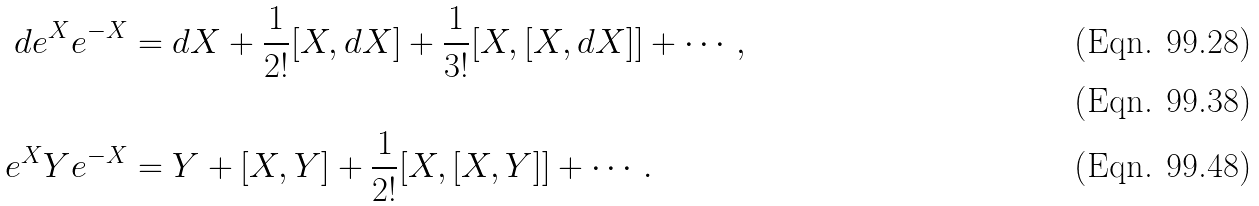<formula> <loc_0><loc_0><loc_500><loc_500>d e ^ { X } e ^ { - X } & = d X + \frac { 1 } { 2 ! } [ X , d X ] + \frac { 1 } { 3 ! } [ X , [ X , d X ] ] + \cdots , \\ \\ e ^ { X } Y e ^ { - X } & = Y + [ X , Y ] + \frac { 1 } { 2 ! } [ X , [ X , Y ] ] + \cdots .</formula> 